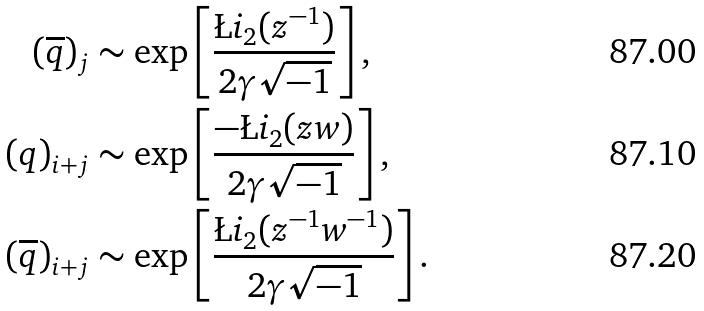<formula> <loc_0><loc_0><loc_500><loc_500>( \overline { q } ) _ { j } & \sim \exp \left [ \frac { \L i _ { 2 } ( z ^ { - 1 } ) } { 2 \gamma \sqrt { - 1 } } \right ] , \\ ( q ) _ { i + j } & \sim \exp \left [ \frac { - \L i _ { 2 } ( z w ) } { 2 \gamma \sqrt { - 1 } } \right ] , \\ ( \overline { q } ) _ { i + j } & \sim \exp \left [ \frac { \L i _ { 2 } ( z ^ { - 1 } w ^ { - 1 } ) } { 2 \gamma \sqrt { - 1 } } \right ] .</formula> 